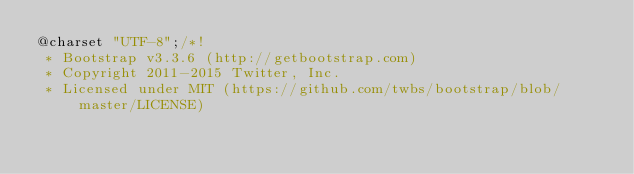<code> <loc_0><loc_0><loc_500><loc_500><_CSS_>@charset "UTF-8";/*!
 * Bootstrap v3.3.6 (http://getbootstrap.com)
 * Copyright 2011-2015 Twitter, Inc.
 * Licensed under MIT (https://github.com/twbs/bootstrap/blob/master/LICENSE)</code> 